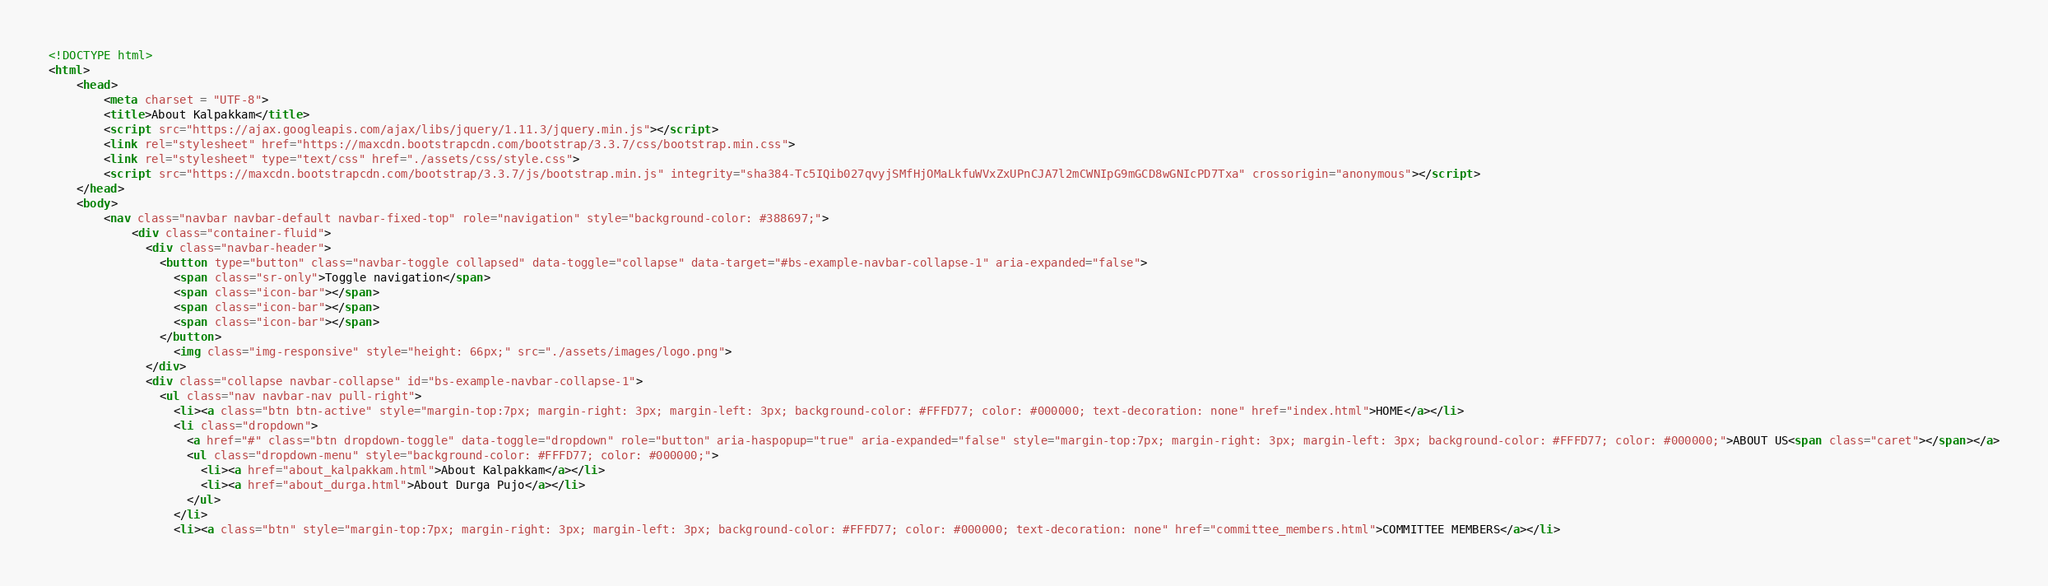Convert code to text. <code><loc_0><loc_0><loc_500><loc_500><_HTML_><!DOCTYPE html>
<html>
	<head>
		<meta charset = "UTF-8">
		<title>About Kalpakkam</title>
		<script src="https://ajax.googleapis.com/ajax/libs/jquery/1.11.3/jquery.min.js"></script>
		<link rel="stylesheet" href="https://maxcdn.bootstrapcdn.com/bootstrap/3.3.7/css/bootstrap.min.css">
		<link rel="stylesheet" type="text/css" href="./assets/css/style.css">
		<script src="https://maxcdn.bootstrapcdn.com/bootstrap/3.3.7/js/bootstrap.min.js" integrity="sha384-Tc5IQib027qvyjSMfHjOMaLkfuWVxZxUPnCJA7l2mCWNIpG9mGCD8wGNIcPD7Txa" crossorigin="anonymous"></script>
	</head>
	<body>
		<nav class="navbar navbar-default navbar-fixed-top" role="navigation" style="background-color: #388697;">
		    <div class="container-fluid">
		      <div class="navbar-header">
		        <button type="button" class="navbar-toggle collapsed" data-toggle="collapse" data-target="#bs-example-navbar-collapse-1" aria-expanded="false">
		          <span class="sr-only">Toggle navigation</span>
		          <span class="icon-bar"></span>
		          <span class="icon-bar"></span>
		          <span class="icon-bar"></span>
		        </button>
		          <img class="img-responsive" style="height: 66px;" src="./assets/images/logo.png">
		      </div>
		      <div class="collapse navbar-collapse" id="bs-example-navbar-collapse-1">
		        <ul class="nav navbar-nav pull-right">
		          <li><a class="btn btn-active" style="margin-top:7px; margin-right: 3px; margin-left: 3px; background-color: #FFFD77; color: #000000; text-decoration: none" href="index.html">HOME</a></li>
		          <li class="dropdown">
		            <a href="#" class="btn dropdown-toggle" data-toggle="dropdown" role="button" aria-haspopup="true" aria-expanded="false" style="margin-top:7px; margin-right: 3px; margin-left: 3px; background-color: #FFFD77; color: #000000;">ABOUT US<span class="caret"></span></a>
		            <ul class="dropdown-menu" style="background-color: #FFFD77; color: #000000;">
		              <li><a href="about_kalpakkam.html">About Kalpakkam</a></li>
		              <li><a href="about_durga.html">About Durga Pujo</a></li>
		            </ul>
		          </li>
		          <li><a class="btn" style="margin-top:7px; margin-right: 3px; margin-left: 3px; background-color: #FFFD77; color: #000000; text-decoration: none" href="committee_members.html">COMMITTEE MEMBERS</a></li></code> 